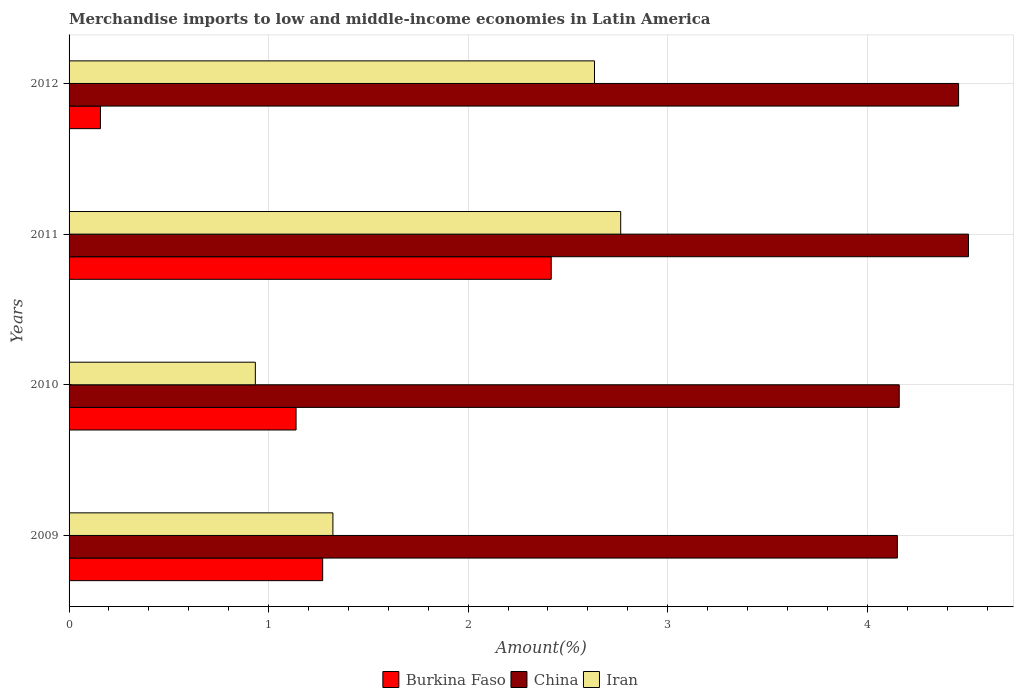Are the number of bars on each tick of the Y-axis equal?
Your answer should be compact. Yes. How many bars are there on the 3rd tick from the top?
Your answer should be compact. 3. How many bars are there on the 4th tick from the bottom?
Provide a succinct answer. 3. What is the percentage of amount earned from merchandise imports in Burkina Faso in 2012?
Offer a terse response. 0.16. Across all years, what is the maximum percentage of amount earned from merchandise imports in Iran?
Provide a short and direct response. 2.76. Across all years, what is the minimum percentage of amount earned from merchandise imports in China?
Ensure brevity in your answer.  4.15. What is the total percentage of amount earned from merchandise imports in Iran in the graph?
Offer a very short reply. 7.65. What is the difference between the percentage of amount earned from merchandise imports in Burkina Faso in 2009 and that in 2012?
Your answer should be very brief. 1.11. What is the difference between the percentage of amount earned from merchandise imports in Iran in 2009 and the percentage of amount earned from merchandise imports in China in 2011?
Provide a short and direct response. -3.19. What is the average percentage of amount earned from merchandise imports in Iran per year?
Offer a very short reply. 1.91. In the year 2011, what is the difference between the percentage of amount earned from merchandise imports in Burkina Faso and percentage of amount earned from merchandise imports in Iran?
Give a very brief answer. -0.35. In how many years, is the percentage of amount earned from merchandise imports in China greater than 2 %?
Offer a terse response. 4. What is the ratio of the percentage of amount earned from merchandise imports in Burkina Faso in 2009 to that in 2012?
Keep it short and to the point. 8.08. Is the percentage of amount earned from merchandise imports in Iran in 2010 less than that in 2011?
Give a very brief answer. Yes. What is the difference between the highest and the second highest percentage of amount earned from merchandise imports in Iran?
Keep it short and to the point. 0.13. What is the difference between the highest and the lowest percentage of amount earned from merchandise imports in China?
Provide a succinct answer. 0.36. What does the 1st bar from the bottom in 2012 represents?
Keep it short and to the point. Burkina Faso. Is it the case that in every year, the sum of the percentage of amount earned from merchandise imports in China and percentage of amount earned from merchandise imports in Iran is greater than the percentage of amount earned from merchandise imports in Burkina Faso?
Keep it short and to the point. Yes. Are all the bars in the graph horizontal?
Your answer should be very brief. Yes. How many years are there in the graph?
Give a very brief answer. 4. What is the difference between two consecutive major ticks on the X-axis?
Make the answer very short. 1. Where does the legend appear in the graph?
Give a very brief answer. Bottom center. What is the title of the graph?
Your answer should be very brief. Merchandise imports to low and middle-income economies in Latin America. Does "Lesotho" appear as one of the legend labels in the graph?
Keep it short and to the point. No. What is the label or title of the X-axis?
Your response must be concise. Amount(%). What is the label or title of the Y-axis?
Your response must be concise. Years. What is the Amount(%) of Burkina Faso in 2009?
Provide a short and direct response. 1.27. What is the Amount(%) in China in 2009?
Ensure brevity in your answer.  4.15. What is the Amount(%) in Iran in 2009?
Provide a short and direct response. 1.32. What is the Amount(%) in Burkina Faso in 2010?
Make the answer very short. 1.14. What is the Amount(%) of China in 2010?
Keep it short and to the point. 4.16. What is the Amount(%) of Iran in 2010?
Give a very brief answer. 0.93. What is the Amount(%) of Burkina Faso in 2011?
Your response must be concise. 2.42. What is the Amount(%) of China in 2011?
Provide a short and direct response. 4.51. What is the Amount(%) in Iran in 2011?
Your response must be concise. 2.76. What is the Amount(%) in Burkina Faso in 2012?
Keep it short and to the point. 0.16. What is the Amount(%) in China in 2012?
Provide a short and direct response. 4.46. What is the Amount(%) in Iran in 2012?
Keep it short and to the point. 2.63. Across all years, what is the maximum Amount(%) in Burkina Faso?
Offer a very short reply. 2.42. Across all years, what is the maximum Amount(%) in China?
Your response must be concise. 4.51. Across all years, what is the maximum Amount(%) in Iran?
Ensure brevity in your answer.  2.76. Across all years, what is the minimum Amount(%) of Burkina Faso?
Your answer should be compact. 0.16. Across all years, what is the minimum Amount(%) of China?
Provide a succinct answer. 4.15. Across all years, what is the minimum Amount(%) of Iran?
Offer a very short reply. 0.93. What is the total Amount(%) of Burkina Faso in the graph?
Provide a short and direct response. 4.98. What is the total Amount(%) in China in the graph?
Ensure brevity in your answer.  17.28. What is the total Amount(%) of Iran in the graph?
Keep it short and to the point. 7.65. What is the difference between the Amount(%) of Burkina Faso in 2009 and that in 2010?
Your answer should be compact. 0.13. What is the difference between the Amount(%) of China in 2009 and that in 2010?
Ensure brevity in your answer.  -0.01. What is the difference between the Amount(%) in Iran in 2009 and that in 2010?
Provide a succinct answer. 0.39. What is the difference between the Amount(%) of Burkina Faso in 2009 and that in 2011?
Provide a succinct answer. -1.15. What is the difference between the Amount(%) of China in 2009 and that in 2011?
Keep it short and to the point. -0.36. What is the difference between the Amount(%) of Iran in 2009 and that in 2011?
Provide a succinct answer. -1.44. What is the difference between the Amount(%) in Burkina Faso in 2009 and that in 2012?
Your answer should be compact. 1.11. What is the difference between the Amount(%) of China in 2009 and that in 2012?
Your response must be concise. -0.31. What is the difference between the Amount(%) of Iran in 2009 and that in 2012?
Make the answer very short. -1.31. What is the difference between the Amount(%) of Burkina Faso in 2010 and that in 2011?
Ensure brevity in your answer.  -1.28. What is the difference between the Amount(%) in China in 2010 and that in 2011?
Make the answer very short. -0.35. What is the difference between the Amount(%) of Iran in 2010 and that in 2011?
Give a very brief answer. -1.83. What is the difference between the Amount(%) of Burkina Faso in 2010 and that in 2012?
Your response must be concise. 0.98. What is the difference between the Amount(%) in China in 2010 and that in 2012?
Your response must be concise. -0.3. What is the difference between the Amount(%) in Iran in 2010 and that in 2012?
Keep it short and to the point. -1.7. What is the difference between the Amount(%) in Burkina Faso in 2011 and that in 2012?
Offer a terse response. 2.26. What is the difference between the Amount(%) in China in 2011 and that in 2012?
Keep it short and to the point. 0.05. What is the difference between the Amount(%) of Iran in 2011 and that in 2012?
Provide a short and direct response. 0.13. What is the difference between the Amount(%) in Burkina Faso in 2009 and the Amount(%) in China in 2010?
Make the answer very short. -2.89. What is the difference between the Amount(%) of Burkina Faso in 2009 and the Amount(%) of Iran in 2010?
Your answer should be compact. 0.34. What is the difference between the Amount(%) of China in 2009 and the Amount(%) of Iran in 2010?
Your answer should be very brief. 3.22. What is the difference between the Amount(%) of Burkina Faso in 2009 and the Amount(%) of China in 2011?
Make the answer very short. -3.24. What is the difference between the Amount(%) of Burkina Faso in 2009 and the Amount(%) of Iran in 2011?
Your response must be concise. -1.49. What is the difference between the Amount(%) of China in 2009 and the Amount(%) of Iran in 2011?
Provide a short and direct response. 1.39. What is the difference between the Amount(%) of Burkina Faso in 2009 and the Amount(%) of China in 2012?
Offer a terse response. -3.19. What is the difference between the Amount(%) of Burkina Faso in 2009 and the Amount(%) of Iran in 2012?
Ensure brevity in your answer.  -1.36. What is the difference between the Amount(%) of China in 2009 and the Amount(%) of Iran in 2012?
Ensure brevity in your answer.  1.52. What is the difference between the Amount(%) in Burkina Faso in 2010 and the Amount(%) in China in 2011?
Keep it short and to the point. -3.37. What is the difference between the Amount(%) of Burkina Faso in 2010 and the Amount(%) of Iran in 2011?
Your answer should be very brief. -1.63. What is the difference between the Amount(%) in China in 2010 and the Amount(%) in Iran in 2011?
Your answer should be very brief. 1.4. What is the difference between the Amount(%) in Burkina Faso in 2010 and the Amount(%) in China in 2012?
Your answer should be compact. -3.32. What is the difference between the Amount(%) of Burkina Faso in 2010 and the Amount(%) of Iran in 2012?
Provide a short and direct response. -1.5. What is the difference between the Amount(%) in China in 2010 and the Amount(%) in Iran in 2012?
Give a very brief answer. 1.53. What is the difference between the Amount(%) in Burkina Faso in 2011 and the Amount(%) in China in 2012?
Provide a short and direct response. -2.04. What is the difference between the Amount(%) of Burkina Faso in 2011 and the Amount(%) of Iran in 2012?
Your answer should be compact. -0.22. What is the difference between the Amount(%) in China in 2011 and the Amount(%) in Iran in 2012?
Ensure brevity in your answer.  1.87. What is the average Amount(%) in Burkina Faso per year?
Offer a terse response. 1.25. What is the average Amount(%) of China per year?
Your answer should be compact. 4.32. What is the average Amount(%) in Iran per year?
Offer a terse response. 1.91. In the year 2009, what is the difference between the Amount(%) of Burkina Faso and Amount(%) of China?
Keep it short and to the point. -2.88. In the year 2009, what is the difference between the Amount(%) in Burkina Faso and Amount(%) in Iran?
Your answer should be compact. -0.05. In the year 2009, what is the difference between the Amount(%) in China and Amount(%) in Iran?
Give a very brief answer. 2.83. In the year 2010, what is the difference between the Amount(%) of Burkina Faso and Amount(%) of China?
Offer a very short reply. -3.02. In the year 2010, what is the difference between the Amount(%) of Burkina Faso and Amount(%) of Iran?
Provide a succinct answer. 0.2. In the year 2010, what is the difference between the Amount(%) in China and Amount(%) in Iran?
Provide a short and direct response. 3.23. In the year 2011, what is the difference between the Amount(%) in Burkina Faso and Amount(%) in China?
Keep it short and to the point. -2.09. In the year 2011, what is the difference between the Amount(%) of Burkina Faso and Amount(%) of Iran?
Ensure brevity in your answer.  -0.35. In the year 2011, what is the difference between the Amount(%) of China and Amount(%) of Iran?
Offer a very short reply. 1.74. In the year 2012, what is the difference between the Amount(%) of Burkina Faso and Amount(%) of China?
Ensure brevity in your answer.  -4.3. In the year 2012, what is the difference between the Amount(%) of Burkina Faso and Amount(%) of Iran?
Offer a very short reply. -2.48. In the year 2012, what is the difference between the Amount(%) of China and Amount(%) of Iran?
Offer a very short reply. 1.82. What is the ratio of the Amount(%) of Burkina Faso in 2009 to that in 2010?
Keep it short and to the point. 1.12. What is the ratio of the Amount(%) of Iran in 2009 to that in 2010?
Your answer should be very brief. 1.42. What is the ratio of the Amount(%) in Burkina Faso in 2009 to that in 2011?
Keep it short and to the point. 0.53. What is the ratio of the Amount(%) in China in 2009 to that in 2011?
Offer a terse response. 0.92. What is the ratio of the Amount(%) in Iran in 2009 to that in 2011?
Provide a succinct answer. 0.48. What is the ratio of the Amount(%) in Burkina Faso in 2009 to that in 2012?
Keep it short and to the point. 8.08. What is the ratio of the Amount(%) of China in 2009 to that in 2012?
Make the answer very short. 0.93. What is the ratio of the Amount(%) in Iran in 2009 to that in 2012?
Provide a short and direct response. 0.5. What is the ratio of the Amount(%) of Burkina Faso in 2010 to that in 2011?
Your response must be concise. 0.47. What is the ratio of the Amount(%) in China in 2010 to that in 2011?
Provide a succinct answer. 0.92. What is the ratio of the Amount(%) in Iran in 2010 to that in 2011?
Provide a short and direct response. 0.34. What is the ratio of the Amount(%) of Burkina Faso in 2010 to that in 2012?
Offer a very short reply. 7.24. What is the ratio of the Amount(%) in Iran in 2010 to that in 2012?
Your answer should be compact. 0.35. What is the ratio of the Amount(%) in Burkina Faso in 2011 to that in 2012?
Give a very brief answer. 15.37. What is the ratio of the Amount(%) in China in 2011 to that in 2012?
Offer a very short reply. 1.01. What is the ratio of the Amount(%) in Iran in 2011 to that in 2012?
Your response must be concise. 1.05. What is the difference between the highest and the second highest Amount(%) of Burkina Faso?
Offer a terse response. 1.15. What is the difference between the highest and the second highest Amount(%) of China?
Your answer should be very brief. 0.05. What is the difference between the highest and the second highest Amount(%) in Iran?
Provide a succinct answer. 0.13. What is the difference between the highest and the lowest Amount(%) in Burkina Faso?
Provide a succinct answer. 2.26. What is the difference between the highest and the lowest Amount(%) of China?
Your answer should be compact. 0.36. What is the difference between the highest and the lowest Amount(%) of Iran?
Make the answer very short. 1.83. 